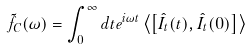Convert formula to latex. <formula><loc_0><loc_0><loc_500><loc_500>\tilde { f } _ { C } ( \omega ) = \int _ { 0 } ^ { \infty } d t e ^ { i \omega t } \left \langle \left [ \hat { I } _ { t } ( t ) , \hat { I } _ { t } ( 0 ) \right ] \right \rangle</formula> 